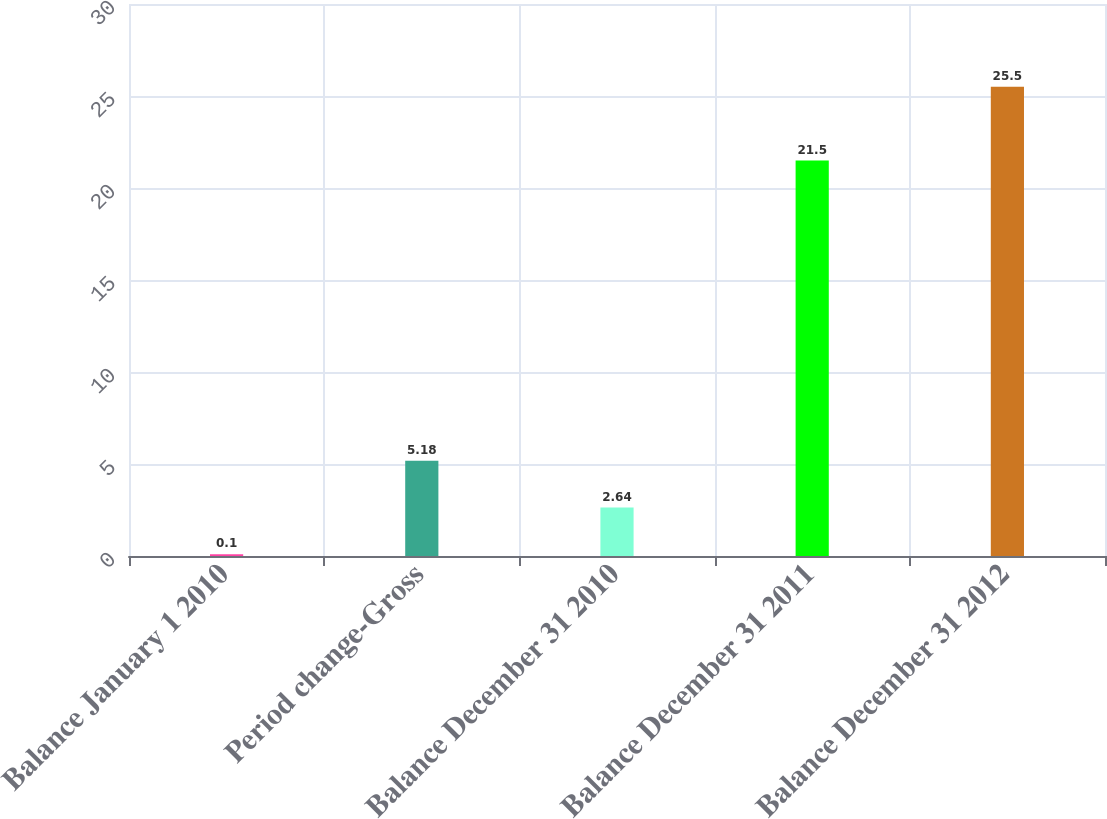<chart> <loc_0><loc_0><loc_500><loc_500><bar_chart><fcel>Balance January 1 2010<fcel>Period change-Gross<fcel>Balance December 31 2010<fcel>Balance December 31 2011<fcel>Balance December 31 2012<nl><fcel>0.1<fcel>5.18<fcel>2.64<fcel>21.5<fcel>25.5<nl></chart> 